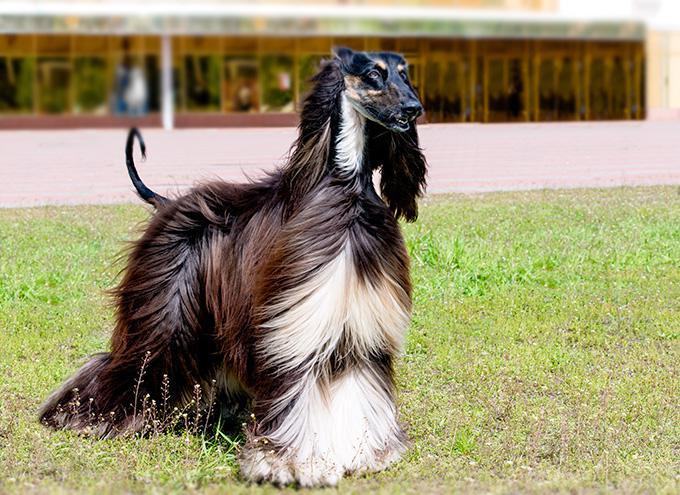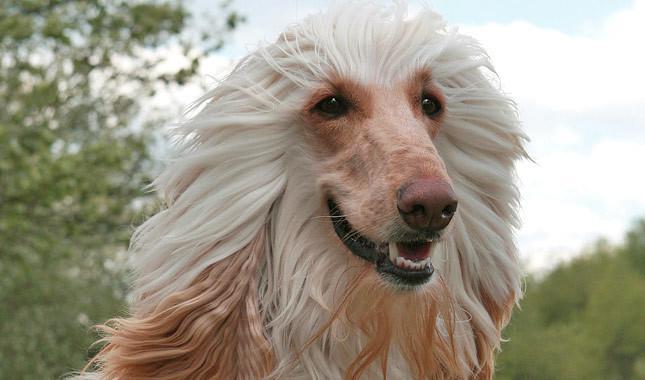The first image is the image on the left, the second image is the image on the right. For the images shown, is this caption "There are back and cream colored dogs" true? Answer yes or no. Yes. 